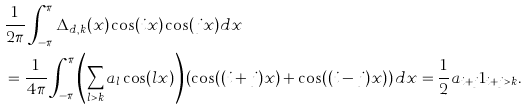Convert formula to latex. <formula><loc_0><loc_0><loc_500><loc_500>& \frac { 1 } { 2 \pi } \int _ { - \pi } ^ { \pi } \Delta _ { d , k } ( x ) \cos ( i x ) \cos ( j x ) d x \\ \quad & = \frac { 1 } { 4 \pi } \int _ { - \pi } ^ { \pi } \left ( \sum _ { l > k } a _ { l } \cos ( l x ) \right ) \left ( \cos ( ( i + j ) x ) + \cos ( ( i - j ) x ) \right ) d x = \frac { 1 } { 2 } a _ { i + j } 1 _ { i + j > k } .</formula> 